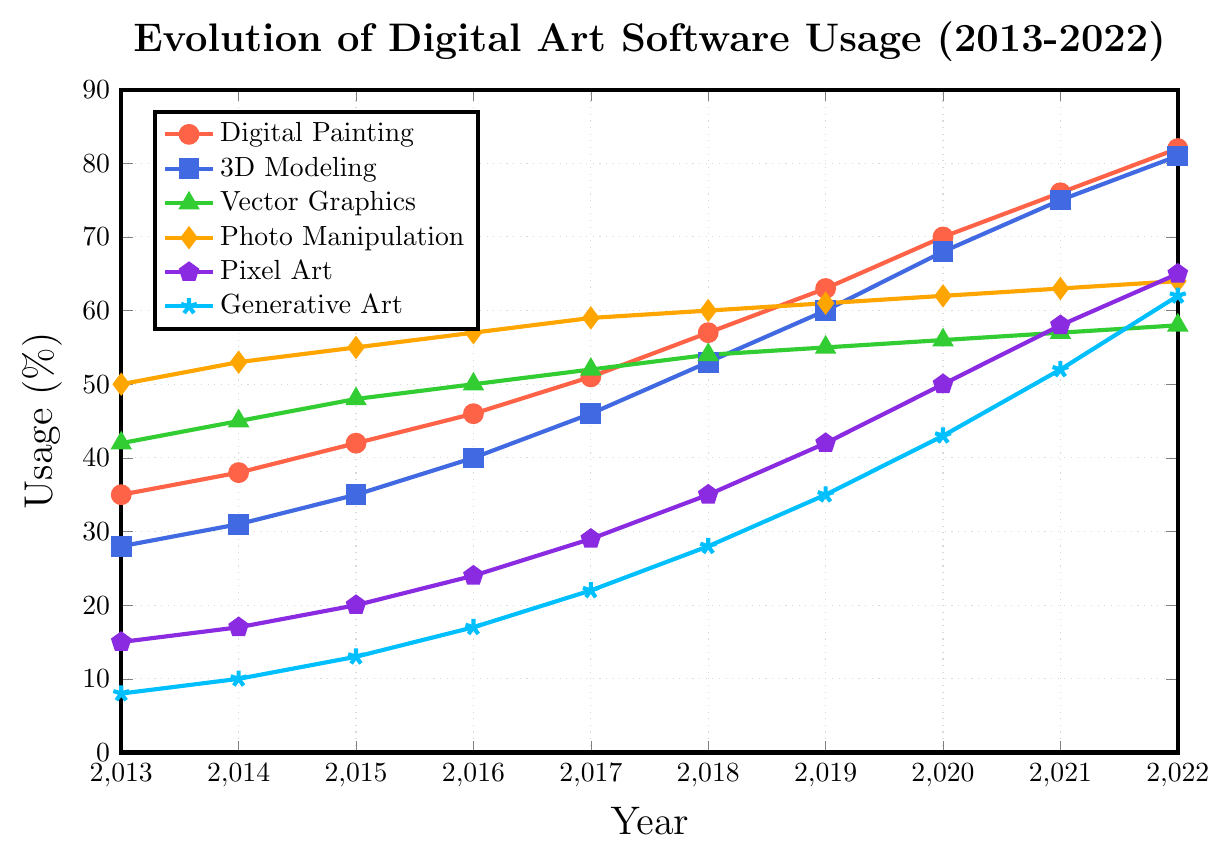What artistic style shows the highest increase in usage from 2013 to 2022? Digital Painting shows the highest increase. The usage in 2013 is 35% and in 2022 it is 82%, which is an increase of 47%.
Answer: Digital Painting Which artistic style had the lowest usage percentage in 2015? In 2015, Generative Art had the lowest usage with 13%. By comparing all styles for the year 2015, this is the lowest value.
Answer: Generative Art What is the average usage percentage of 3D Modeling over the decade? First, sum all yearly percentages for 3D Modeling: 28 + 31 + 35 + 40 + 46 + 53 + 60 + 68 + 75 + 81 = 517. Divide by the number of years, which is 10, giving us 517 / 10 = 51.7%.
Answer: 51.7% Between which consecutive years did Photo Manipulation see the smallest increase in usage? Photo Manipulation’s yearly usage is: 50, 53, 55, 57, 59, 60, 61, 62, 63, 64. The smallest increase is between 2017 and 2018, from 59% to 60%, with an increase of 1%.
Answer: 2017 to 2018 How much did Pixel Art usage increase from 2018 to 2022? Pixel Art usage in 2018 is 35% and in 2022 it is 65%. The increase is 65% - 35% = 30%.
Answer: 30% In what year did Generative Art usage surpass 3D Modeling usage in percentage terms? Generative Art starts to surpass 3D Modeling in 2022, where Generative Art usage is 62% and 3D Modeling usage is 81%.
Answer: Never What’s the median value of Digital Painting usage over the decade? Digital Painting yearly usages are: 35, 38, 42, 46, 51, 57, 63, 70, 76, 82. Ordering them and finding the median (5th and 6th values), (51 + 57)/2 = 54.
Answer: 54 Which artistic style showed the most consistent growth over the decade? Vector Graphics showed the most consistent growth. Its usage increased steadily from 42% in 2013 to 58% in 2022, increasing by roughly 1-3% each year.
Answer: Vector Graphics 